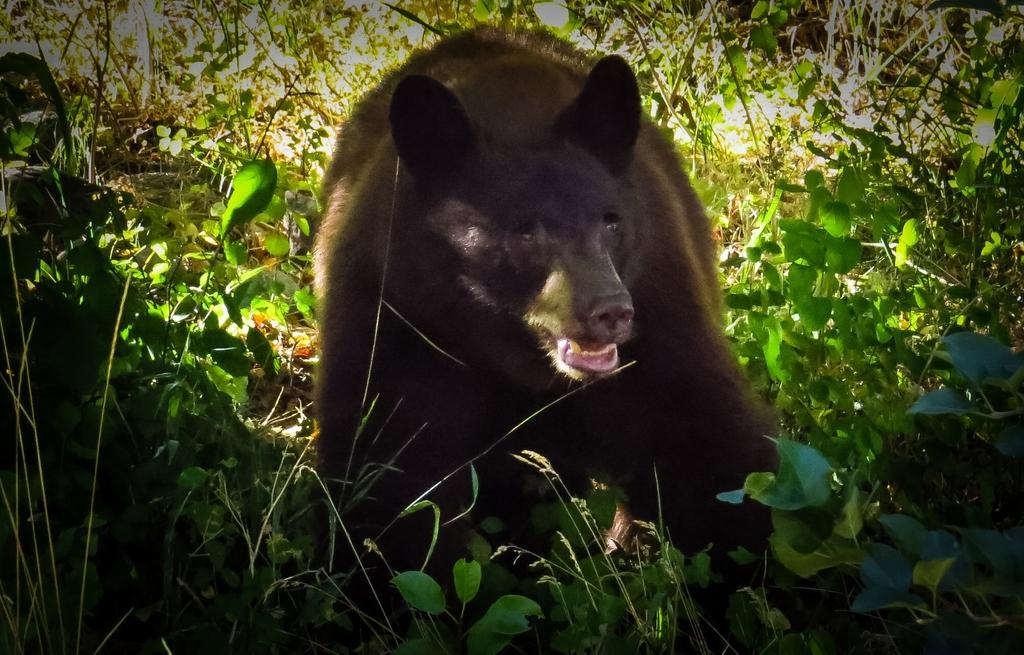What animal is in the middle of the picture? There is a bear in the middle of the picture. What type of vegetation is at the bottom of the picture? There are shrubs at the bottom of the picture. What can be seen in the background of the picture? There are trees in the background of the picture. What type of ring can be seen on the bear's paw in the image? There is no ring present on the bear's paw in the image. 